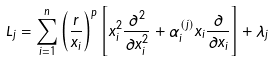<formula> <loc_0><loc_0><loc_500><loc_500>L _ { j } = \sum _ { i = 1 } ^ { n } \left ( \frac { r } { x _ { i } } \right ) ^ { p } \left [ x _ { i } ^ { 2 } \frac { \partial ^ { 2 } } { \partial x _ { i } ^ { 2 } } + \alpha _ { i } ^ { ( j ) } x _ { i } \frac { \partial } { \partial x _ { i } } \right ] + \lambda _ { j }</formula> 